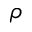Convert formula to latex. <formula><loc_0><loc_0><loc_500><loc_500>\rho</formula> 